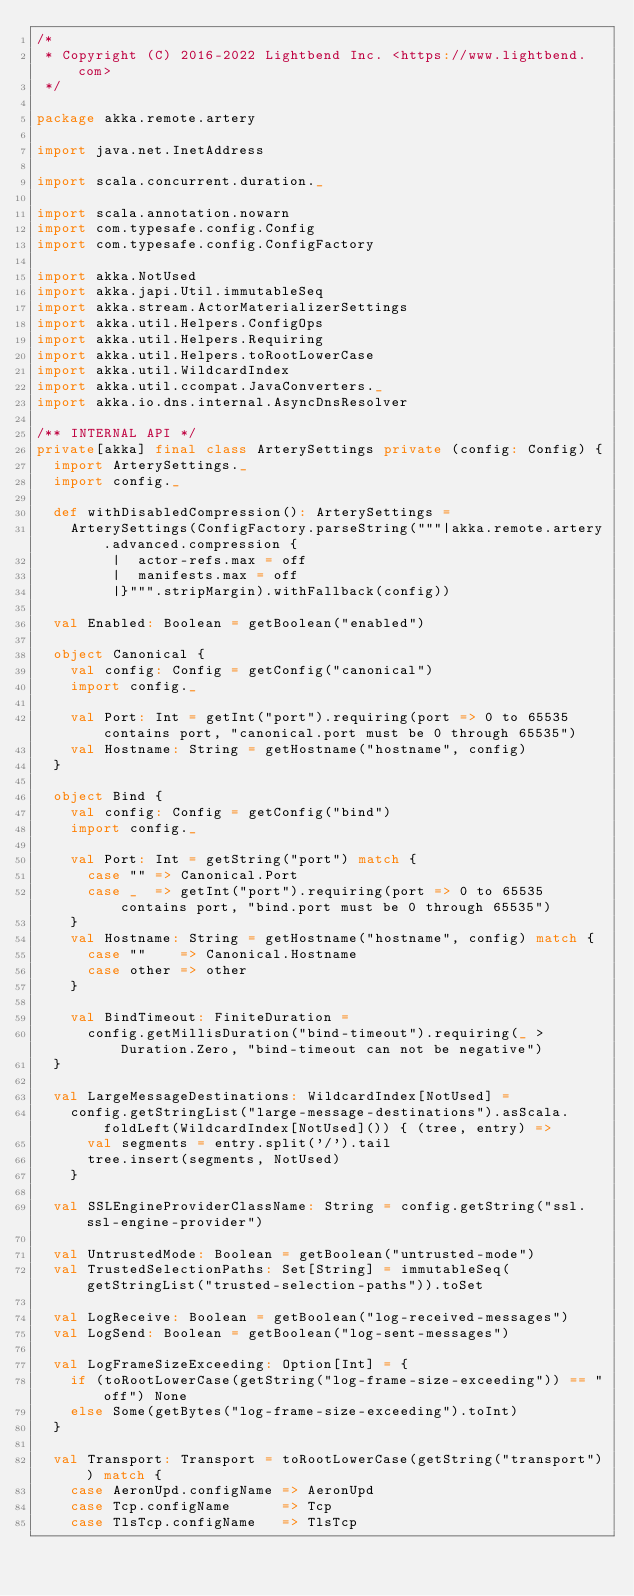<code> <loc_0><loc_0><loc_500><loc_500><_Scala_>/*
 * Copyright (C) 2016-2022 Lightbend Inc. <https://www.lightbend.com>
 */

package akka.remote.artery

import java.net.InetAddress

import scala.concurrent.duration._

import scala.annotation.nowarn
import com.typesafe.config.Config
import com.typesafe.config.ConfigFactory

import akka.NotUsed
import akka.japi.Util.immutableSeq
import akka.stream.ActorMaterializerSettings
import akka.util.Helpers.ConfigOps
import akka.util.Helpers.Requiring
import akka.util.Helpers.toRootLowerCase
import akka.util.WildcardIndex
import akka.util.ccompat.JavaConverters._
import akka.io.dns.internal.AsyncDnsResolver

/** INTERNAL API */
private[akka] final class ArterySettings private (config: Config) {
  import ArterySettings._
  import config._

  def withDisabledCompression(): ArterySettings =
    ArterySettings(ConfigFactory.parseString("""|akka.remote.artery.advanced.compression {
         |  actor-refs.max = off
         |  manifests.max = off
         |}""".stripMargin).withFallback(config))

  val Enabled: Boolean = getBoolean("enabled")

  object Canonical {
    val config: Config = getConfig("canonical")
    import config._

    val Port: Int = getInt("port").requiring(port => 0 to 65535 contains port, "canonical.port must be 0 through 65535")
    val Hostname: String = getHostname("hostname", config)
  }

  object Bind {
    val config: Config = getConfig("bind")
    import config._

    val Port: Int = getString("port") match {
      case "" => Canonical.Port
      case _  => getInt("port").requiring(port => 0 to 65535 contains port, "bind.port must be 0 through 65535")
    }
    val Hostname: String = getHostname("hostname", config) match {
      case ""    => Canonical.Hostname
      case other => other
    }

    val BindTimeout: FiniteDuration =
      config.getMillisDuration("bind-timeout").requiring(_ > Duration.Zero, "bind-timeout can not be negative")
  }

  val LargeMessageDestinations: WildcardIndex[NotUsed] =
    config.getStringList("large-message-destinations").asScala.foldLeft(WildcardIndex[NotUsed]()) { (tree, entry) =>
      val segments = entry.split('/').tail
      tree.insert(segments, NotUsed)
    }

  val SSLEngineProviderClassName: String = config.getString("ssl.ssl-engine-provider")

  val UntrustedMode: Boolean = getBoolean("untrusted-mode")
  val TrustedSelectionPaths: Set[String] = immutableSeq(getStringList("trusted-selection-paths")).toSet

  val LogReceive: Boolean = getBoolean("log-received-messages")
  val LogSend: Boolean = getBoolean("log-sent-messages")

  val LogFrameSizeExceeding: Option[Int] = {
    if (toRootLowerCase(getString("log-frame-size-exceeding")) == "off") None
    else Some(getBytes("log-frame-size-exceeding").toInt)
  }

  val Transport: Transport = toRootLowerCase(getString("transport")) match {
    case AeronUpd.configName => AeronUpd
    case Tcp.configName      => Tcp
    case TlsTcp.configName   => TlsTcp</code> 